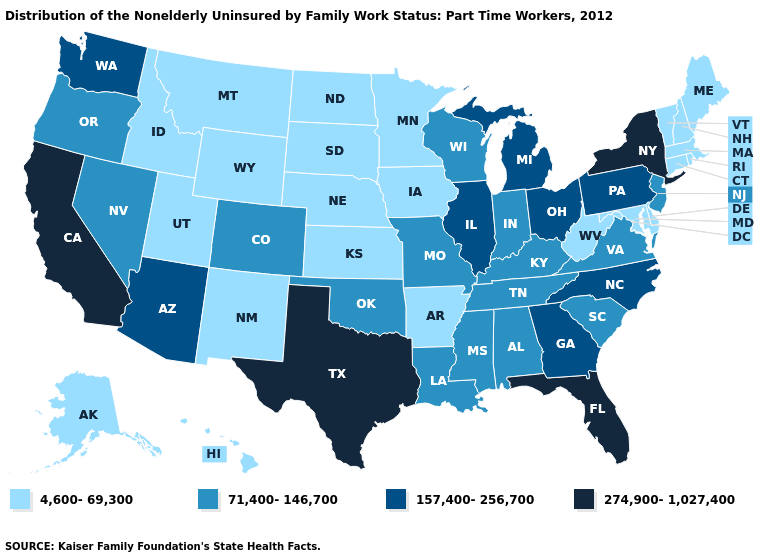What is the value of Iowa?
Write a very short answer. 4,600-69,300. What is the value of North Dakota?
Quick response, please. 4,600-69,300. Among the states that border Wyoming , does Colorado have the lowest value?
Quick response, please. No. Which states have the highest value in the USA?
Quick response, please. California, Florida, New York, Texas. What is the highest value in states that border California?
Short answer required. 157,400-256,700. Name the states that have a value in the range 274,900-1,027,400?
Answer briefly. California, Florida, New York, Texas. Does Colorado have the same value as Mississippi?
Write a very short answer. Yes. Name the states that have a value in the range 157,400-256,700?
Short answer required. Arizona, Georgia, Illinois, Michigan, North Carolina, Ohio, Pennsylvania, Washington. Does Wisconsin have the lowest value in the USA?
Quick response, please. No. Does Utah have the lowest value in the West?
Keep it brief. Yes. Name the states that have a value in the range 71,400-146,700?
Quick response, please. Alabama, Colorado, Indiana, Kentucky, Louisiana, Mississippi, Missouri, Nevada, New Jersey, Oklahoma, Oregon, South Carolina, Tennessee, Virginia, Wisconsin. Does Virginia have the lowest value in the South?
Keep it brief. No. What is the lowest value in the MidWest?
Be succinct. 4,600-69,300. Which states have the lowest value in the South?
Quick response, please. Arkansas, Delaware, Maryland, West Virginia. Is the legend a continuous bar?
Concise answer only. No. 